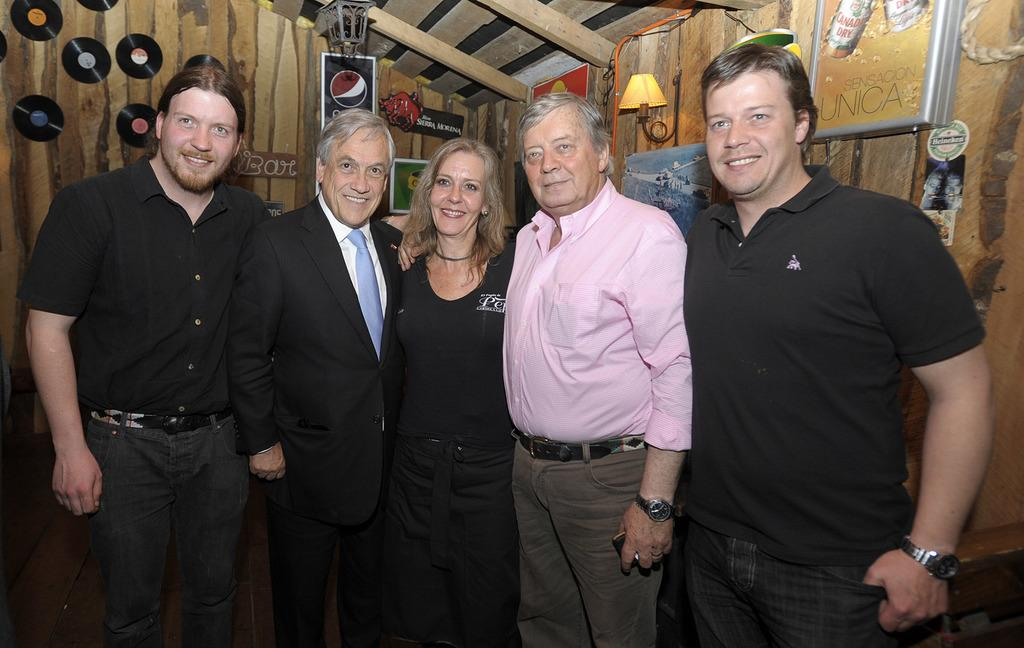What type of structure is visible in the image? There is a wall in the image. Can you describe the people in the image? There is a group of people standing in the image. What type of furniture can be seen in the image? There are desks in the image. What type of lighting is present in the image? There is a lamp in the image. What type of decorations are on the wall in the image? There are posters in the image. What invention is being demonstrated by the group of people in the image? There is no invention being demonstrated in the image; it simply shows a group of people standing near a wall with desks, a lamp, and posters. 